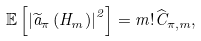<formula> <loc_0><loc_0><loc_500><loc_500>\mathbb { E } \left [ \left | \widetilde { a } _ { \pi } \left ( H _ { m } \right ) \right | ^ { 2 } \right ] = m ! \widehat { C } _ { \pi , m } ,</formula> 